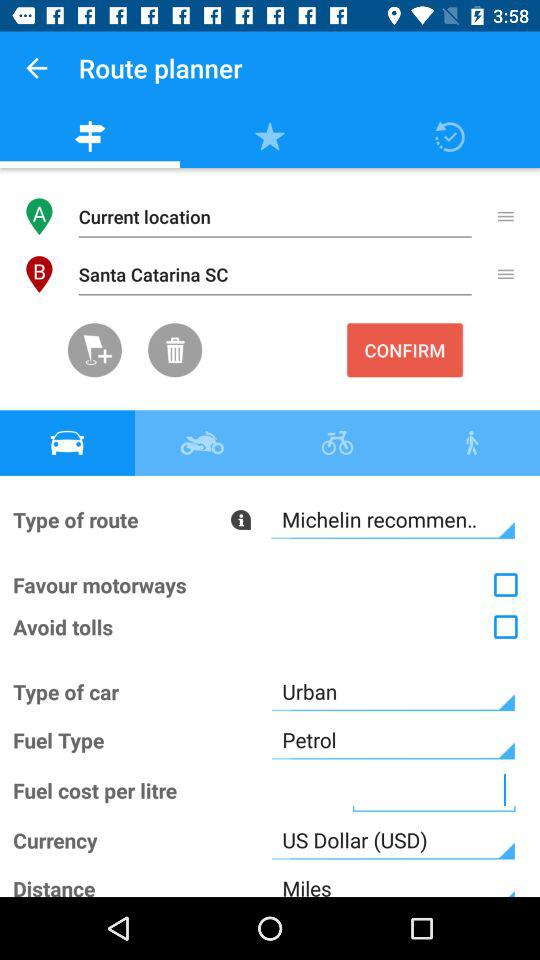What is the type of fuel? The type of fuel is "Petrol". 